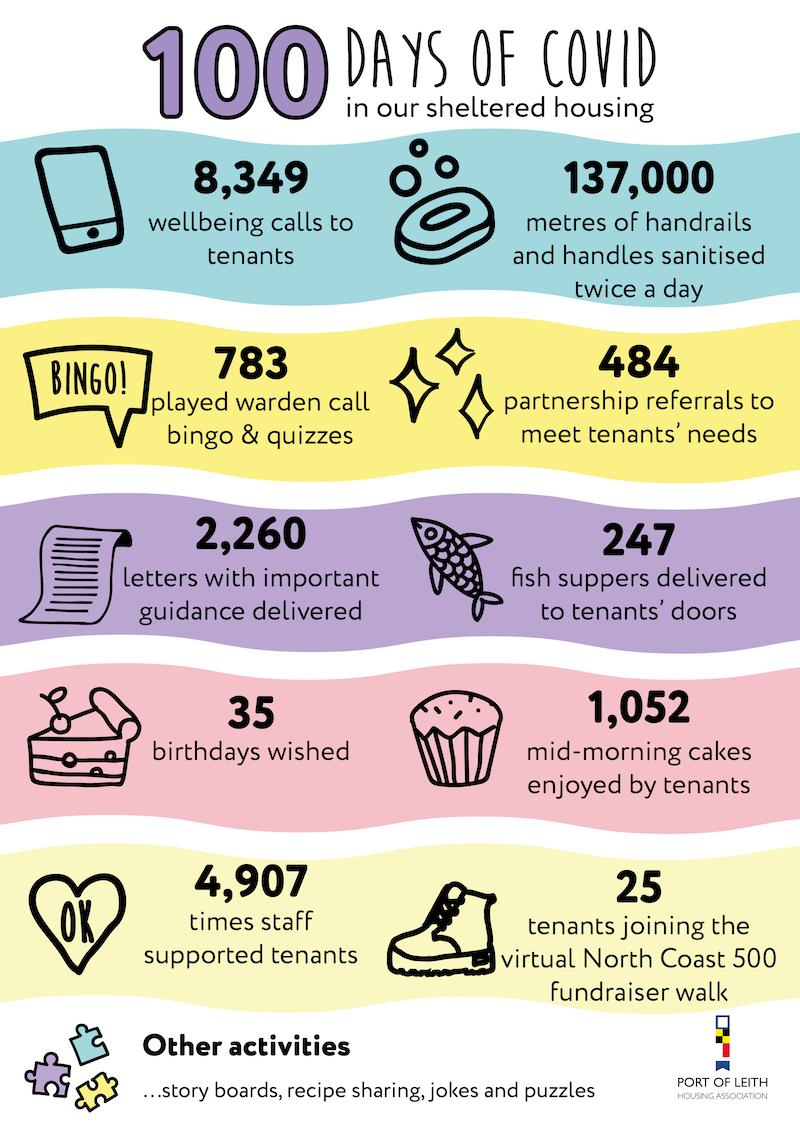Specify some key components in this picture. Port of Leith Housing Association's staff provided support to tenants a total of 4,907 times during the COVID-19 pandemic. During the COVID-19 pandemic, the Port of Leith Housing Association made a total of 8,349 wellbeing calls to its tenants. During the COVID-19 pandemic, the Port of Leith Housing Association delivered a total of 247 fish suppers to the tenants' doors. 